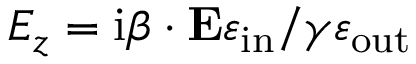<formula> <loc_0><loc_0><loc_500><loc_500>E _ { z } = i \beta \cdot E \varepsilon _ { i n } / \gamma \varepsilon _ { o u t }</formula> 